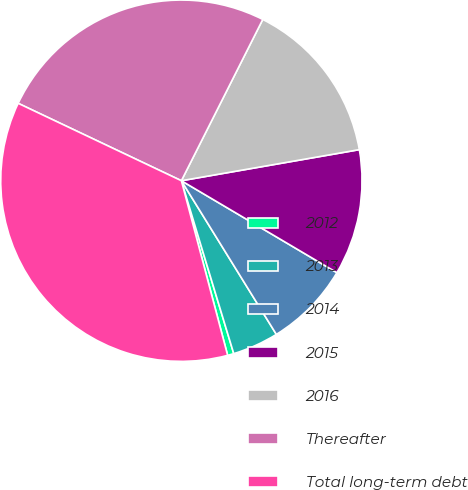Convert chart to OTSL. <chart><loc_0><loc_0><loc_500><loc_500><pie_chart><fcel>2012<fcel>2013<fcel>2014<fcel>2015<fcel>2016<fcel>Thereafter<fcel>Total long-term debt<nl><fcel>0.56%<fcel>4.13%<fcel>7.69%<fcel>11.25%<fcel>14.81%<fcel>25.39%<fcel>36.17%<nl></chart> 